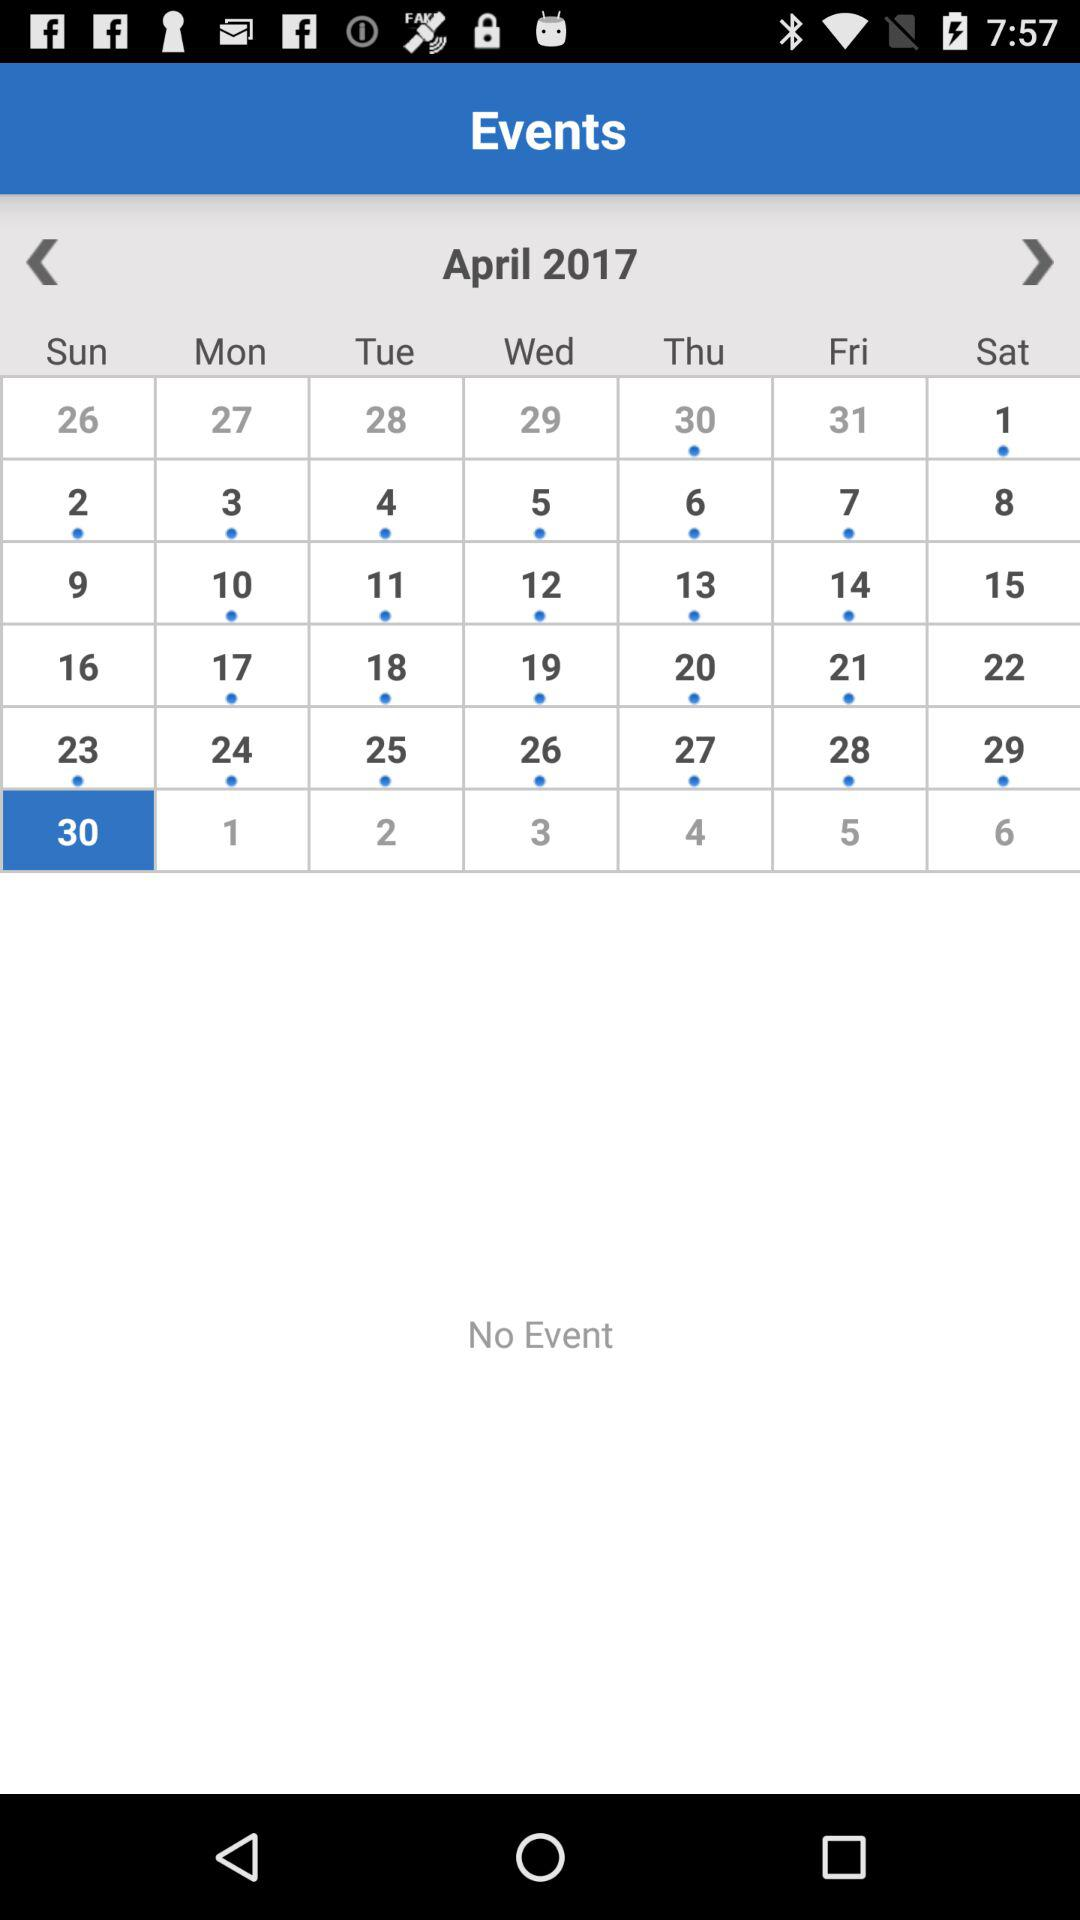How many events are there on the selected date? There are no events on the selected date. 